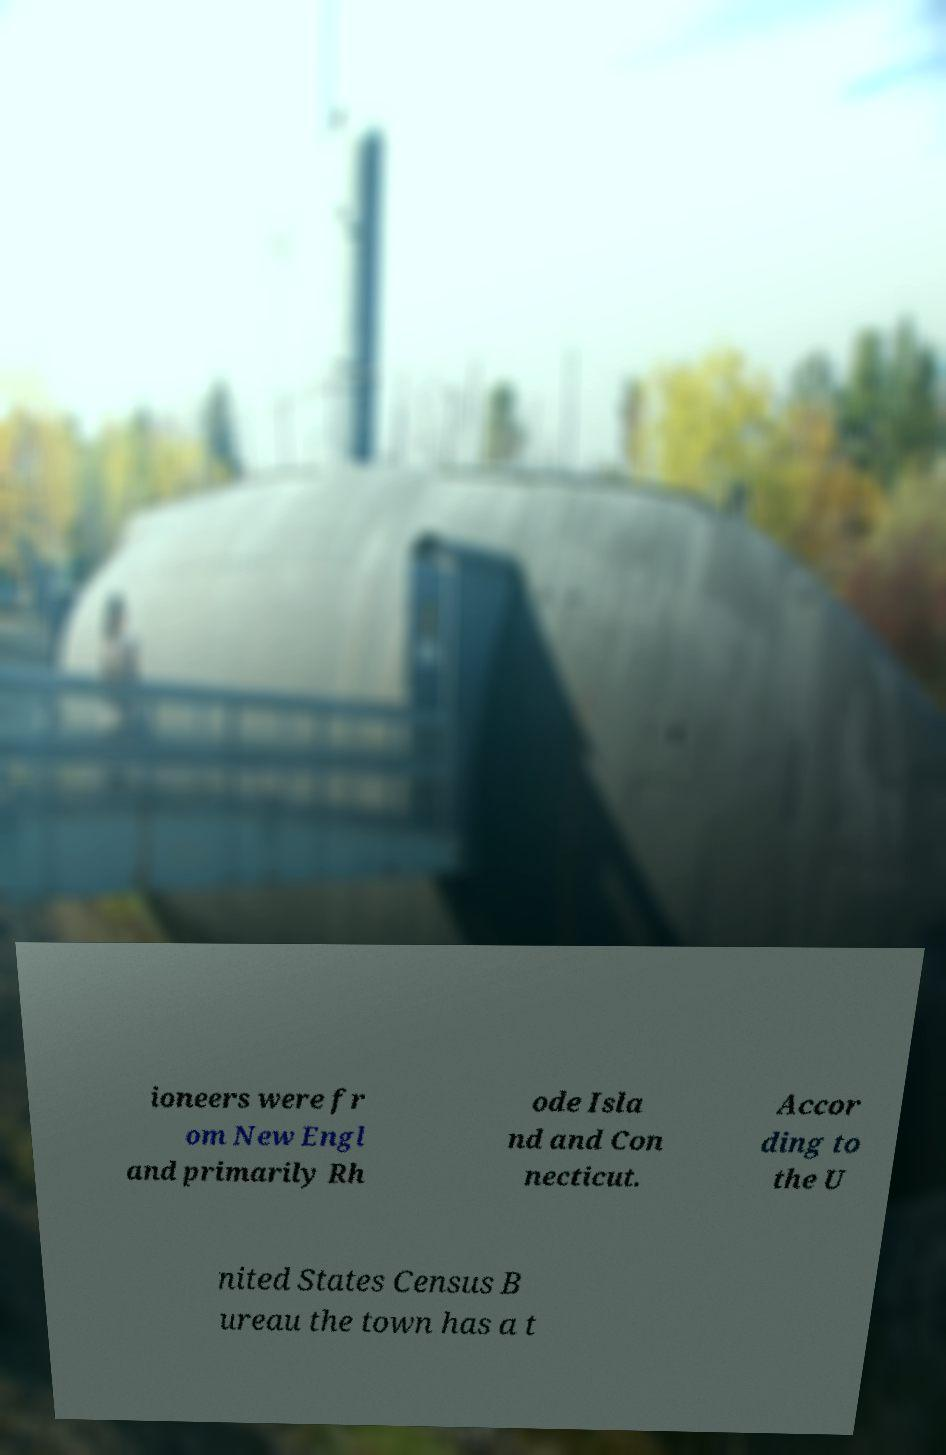Can you read and provide the text displayed in the image?This photo seems to have some interesting text. Can you extract and type it out for me? ioneers were fr om New Engl and primarily Rh ode Isla nd and Con necticut. Accor ding to the U nited States Census B ureau the town has a t 